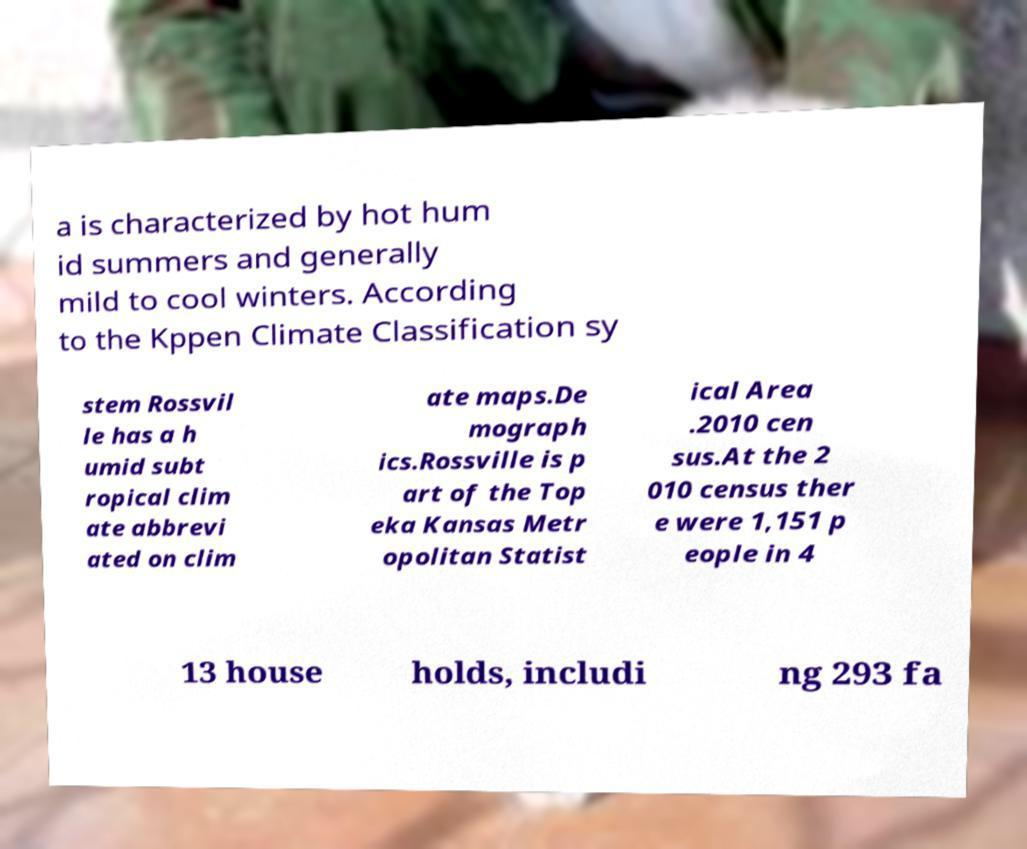For documentation purposes, I need the text within this image transcribed. Could you provide that? a is characterized by hot hum id summers and generally mild to cool winters. According to the Kppen Climate Classification sy stem Rossvil le has a h umid subt ropical clim ate abbrevi ated on clim ate maps.De mograph ics.Rossville is p art of the Top eka Kansas Metr opolitan Statist ical Area .2010 cen sus.At the 2 010 census ther e were 1,151 p eople in 4 13 house holds, includi ng 293 fa 